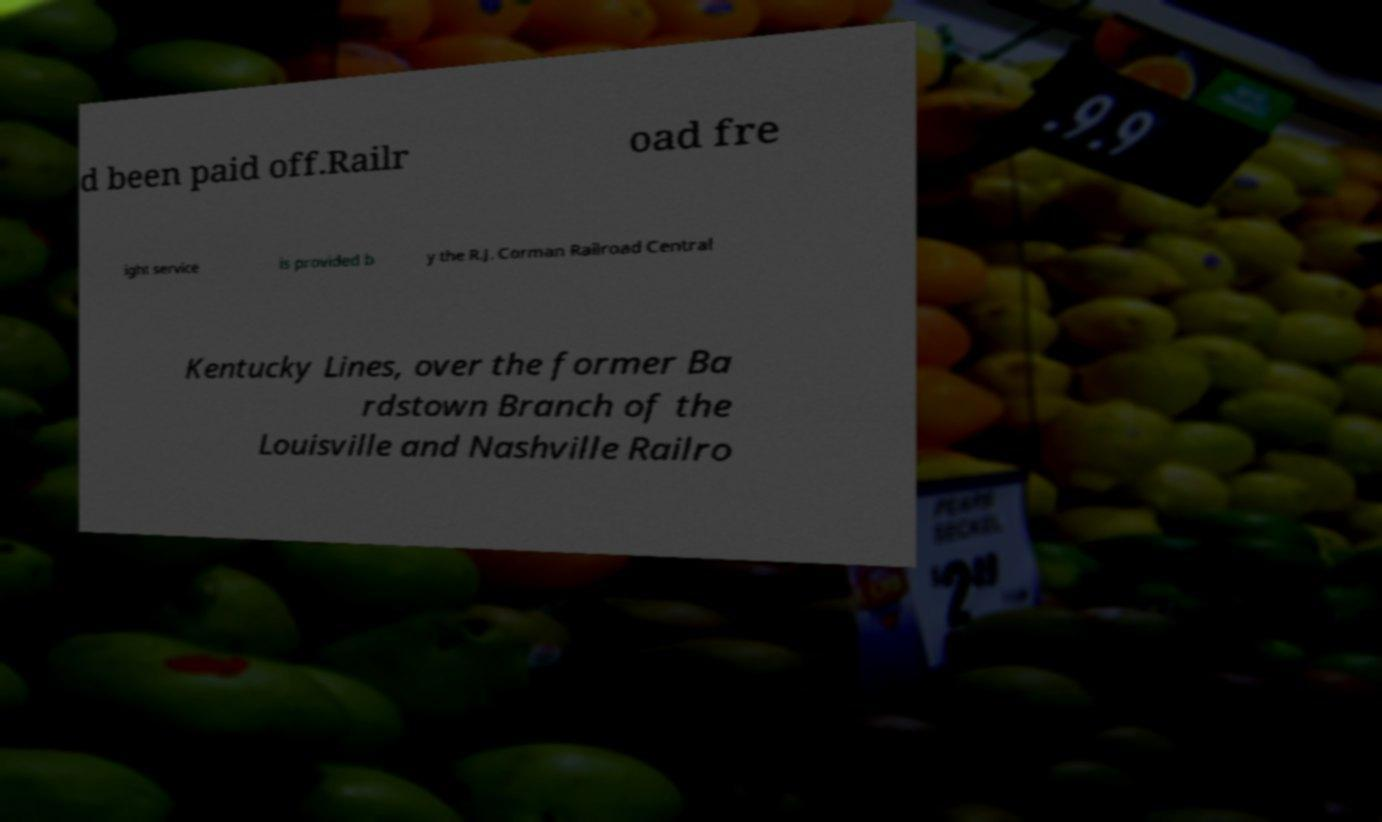Please identify and transcribe the text found in this image. d been paid off.Railr oad fre ight service is provided b y the R.J. Corman Railroad Central Kentucky Lines, over the former Ba rdstown Branch of the Louisville and Nashville Railro 